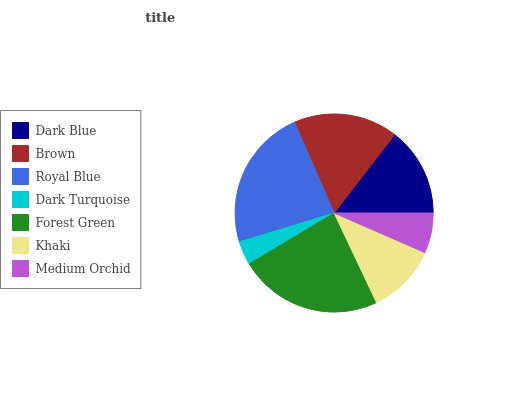Is Dark Turquoise the minimum?
Answer yes or no. Yes. Is Forest Green the maximum?
Answer yes or no. Yes. Is Brown the minimum?
Answer yes or no. No. Is Brown the maximum?
Answer yes or no. No. Is Brown greater than Dark Blue?
Answer yes or no. Yes. Is Dark Blue less than Brown?
Answer yes or no. Yes. Is Dark Blue greater than Brown?
Answer yes or no. No. Is Brown less than Dark Blue?
Answer yes or no. No. Is Dark Blue the high median?
Answer yes or no. Yes. Is Dark Blue the low median?
Answer yes or no. Yes. Is Forest Green the high median?
Answer yes or no. No. Is Khaki the low median?
Answer yes or no. No. 